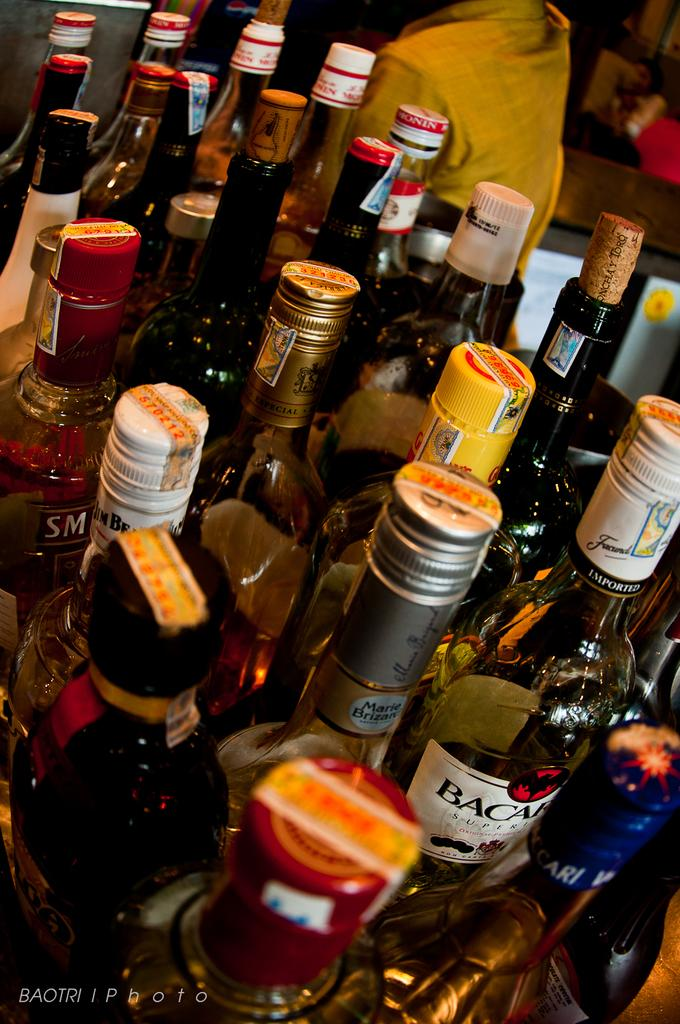Provide a one-sentence caption for the provided image. A cluster of liquor bottles including Bacardi are in a restaurant. 